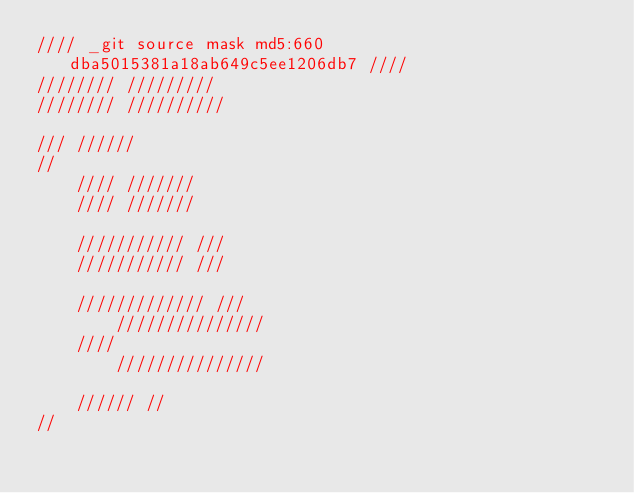Convert code to text. <code><loc_0><loc_0><loc_500><loc_500><_C_>//// _git source mask md5:660dba5015381a18ab649c5ee1206db7 ////
//////// /////////
//////// //////////

/// //////
//
	//// ///////
	//// ///////

	/////////// ///
	/////////// ///

	///////////// ///
		///////////////
	////
		///////////////

	////// //
//
</code> 